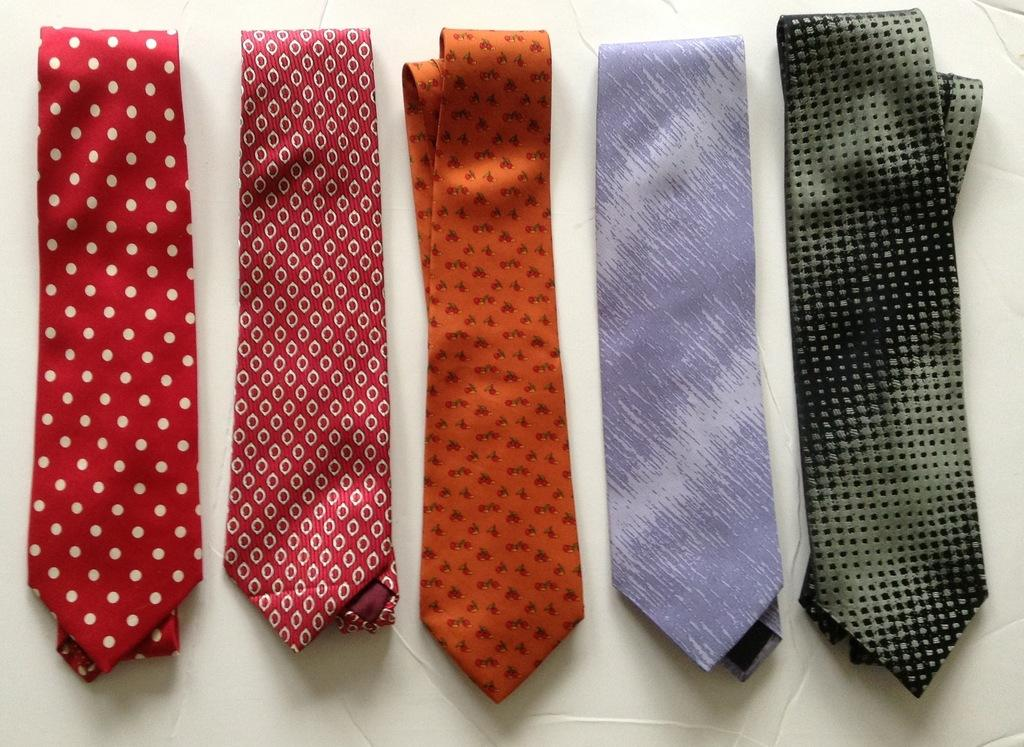How many ties are visible in the image? There are five different ties in the image. What is the color of the surface on which the ties are placed? The ties are placed on a white surface. Are there any boats visible in the image? No, there are no boats present in the image. What type of twig can be seen interacting with the ties in the image? There is no twig present in the image; it only features ties placed on a white surface. 